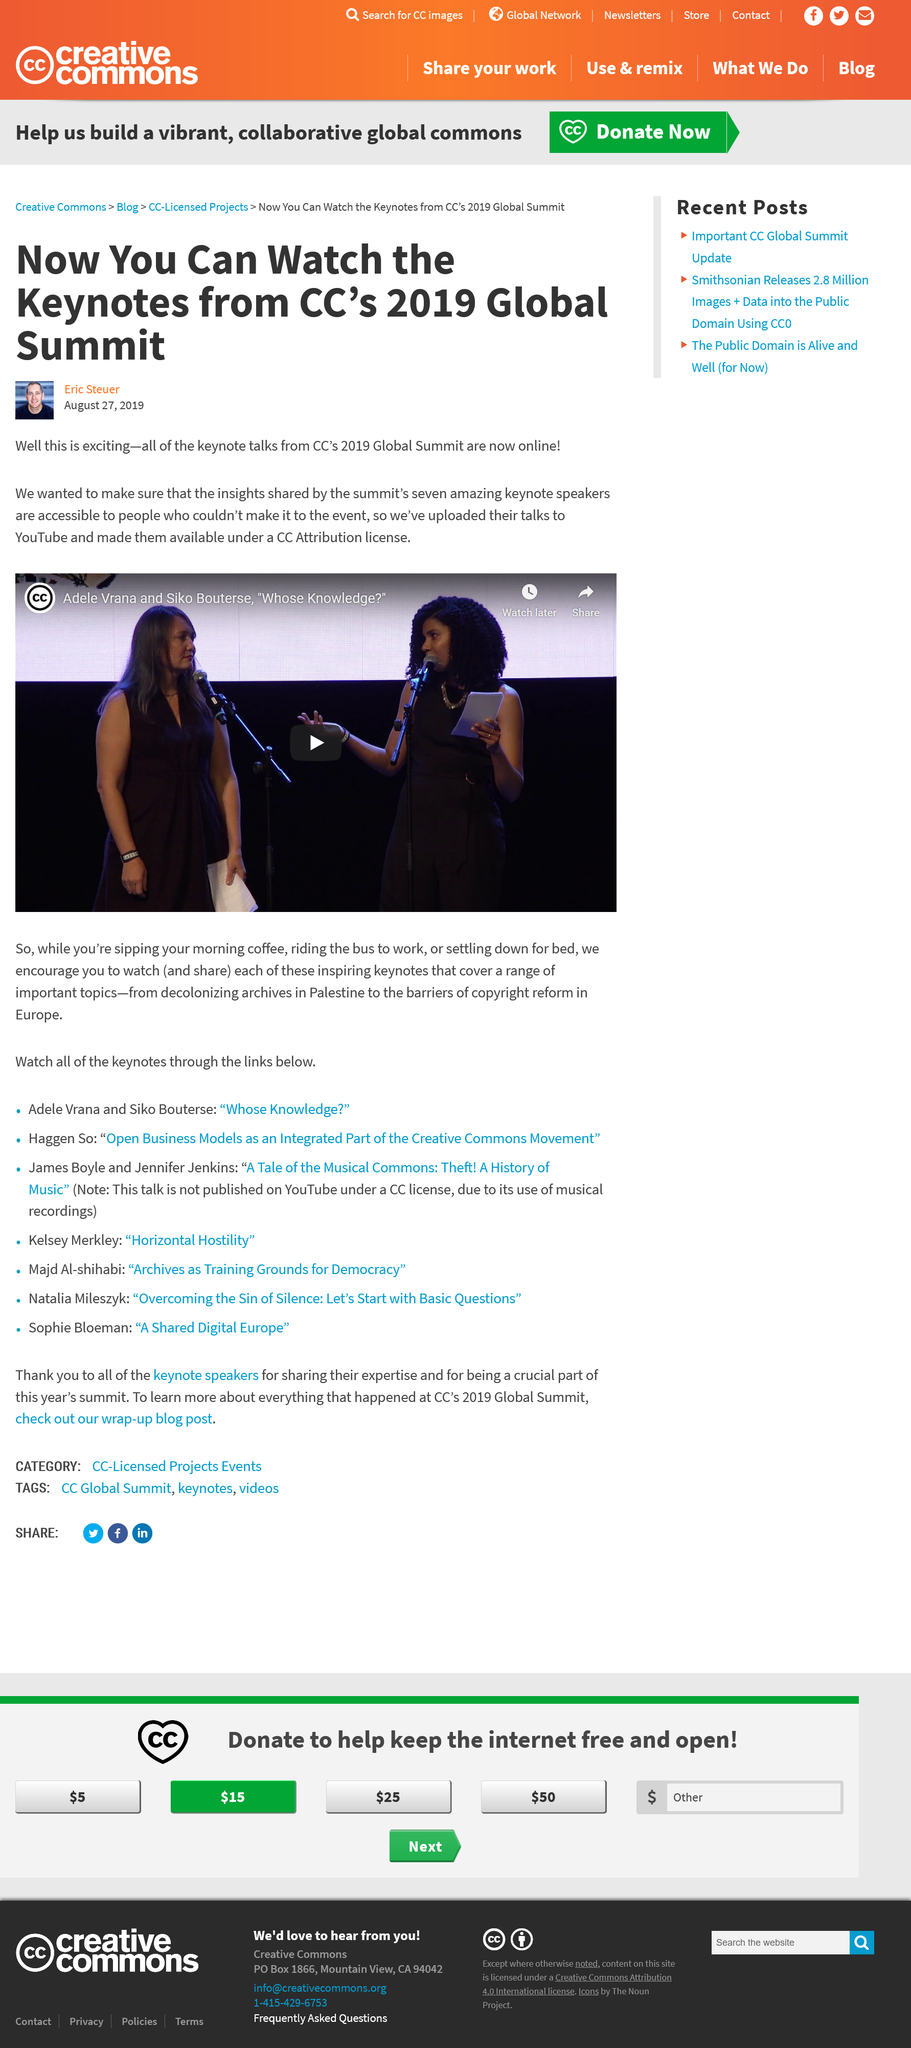Highlight a few significant elements in this photo. The keynote talks were made available on YouTube by the CC Attribution license. The keynote presentation covers the barriers to copyright reform in the continent of Europe. The keynote talks from the 2019 Global Summit hosted by Creative Commons have been uploaded to YouTube. 